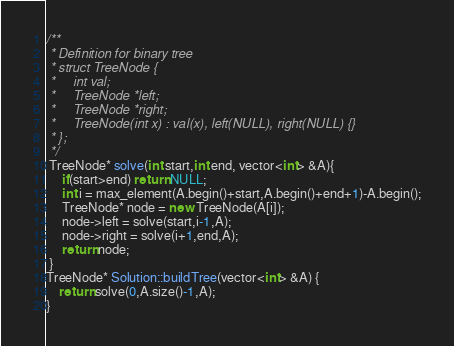Convert code to text. <code><loc_0><loc_0><loc_500><loc_500><_C++_>/**
 * Definition for binary tree
 * struct TreeNode {
 *     int val;
 *     TreeNode *left;
 *     TreeNode *right;
 *     TreeNode(int x) : val(x), left(NULL), right(NULL) {}
 * };
 */
 TreeNode* solve(int start,int end, vector<int> &A){
     if(start>end) return NULL;
     int i = max_element(A.begin()+start,A.begin()+end+1)-A.begin();
     TreeNode* node = new TreeNode(A[i]);
     node->left = solve(start,i-1,A);
     node->right = solve(i+1,end,A);
     return node;
 }
TreeNode* Solution::buildTree(vector<int> &A) {
    return solve(0,A.size()-1,A);
}
</code> 